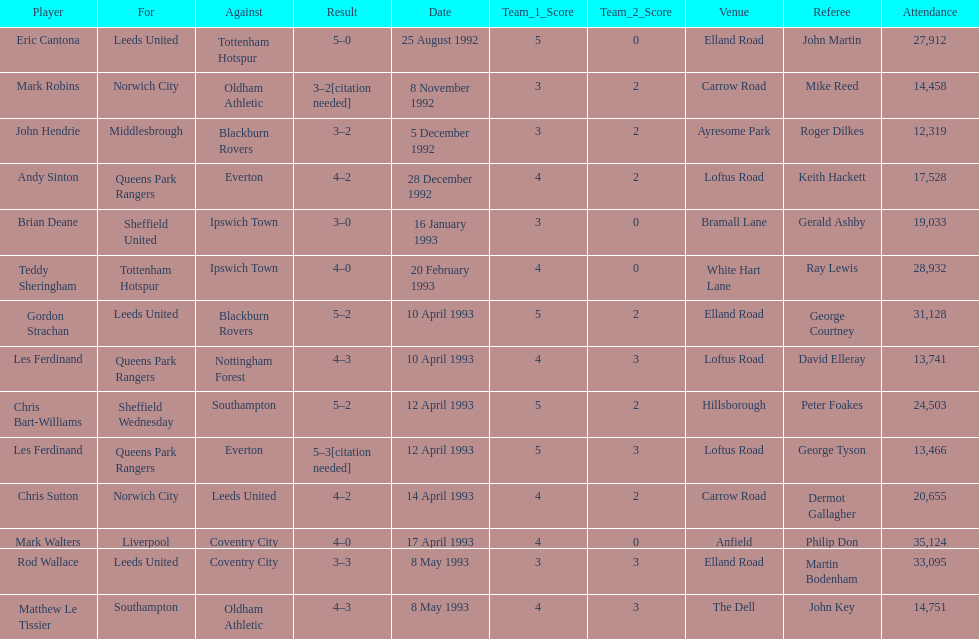Name the players for tottenham hotspur. Teddy Sheringham. 